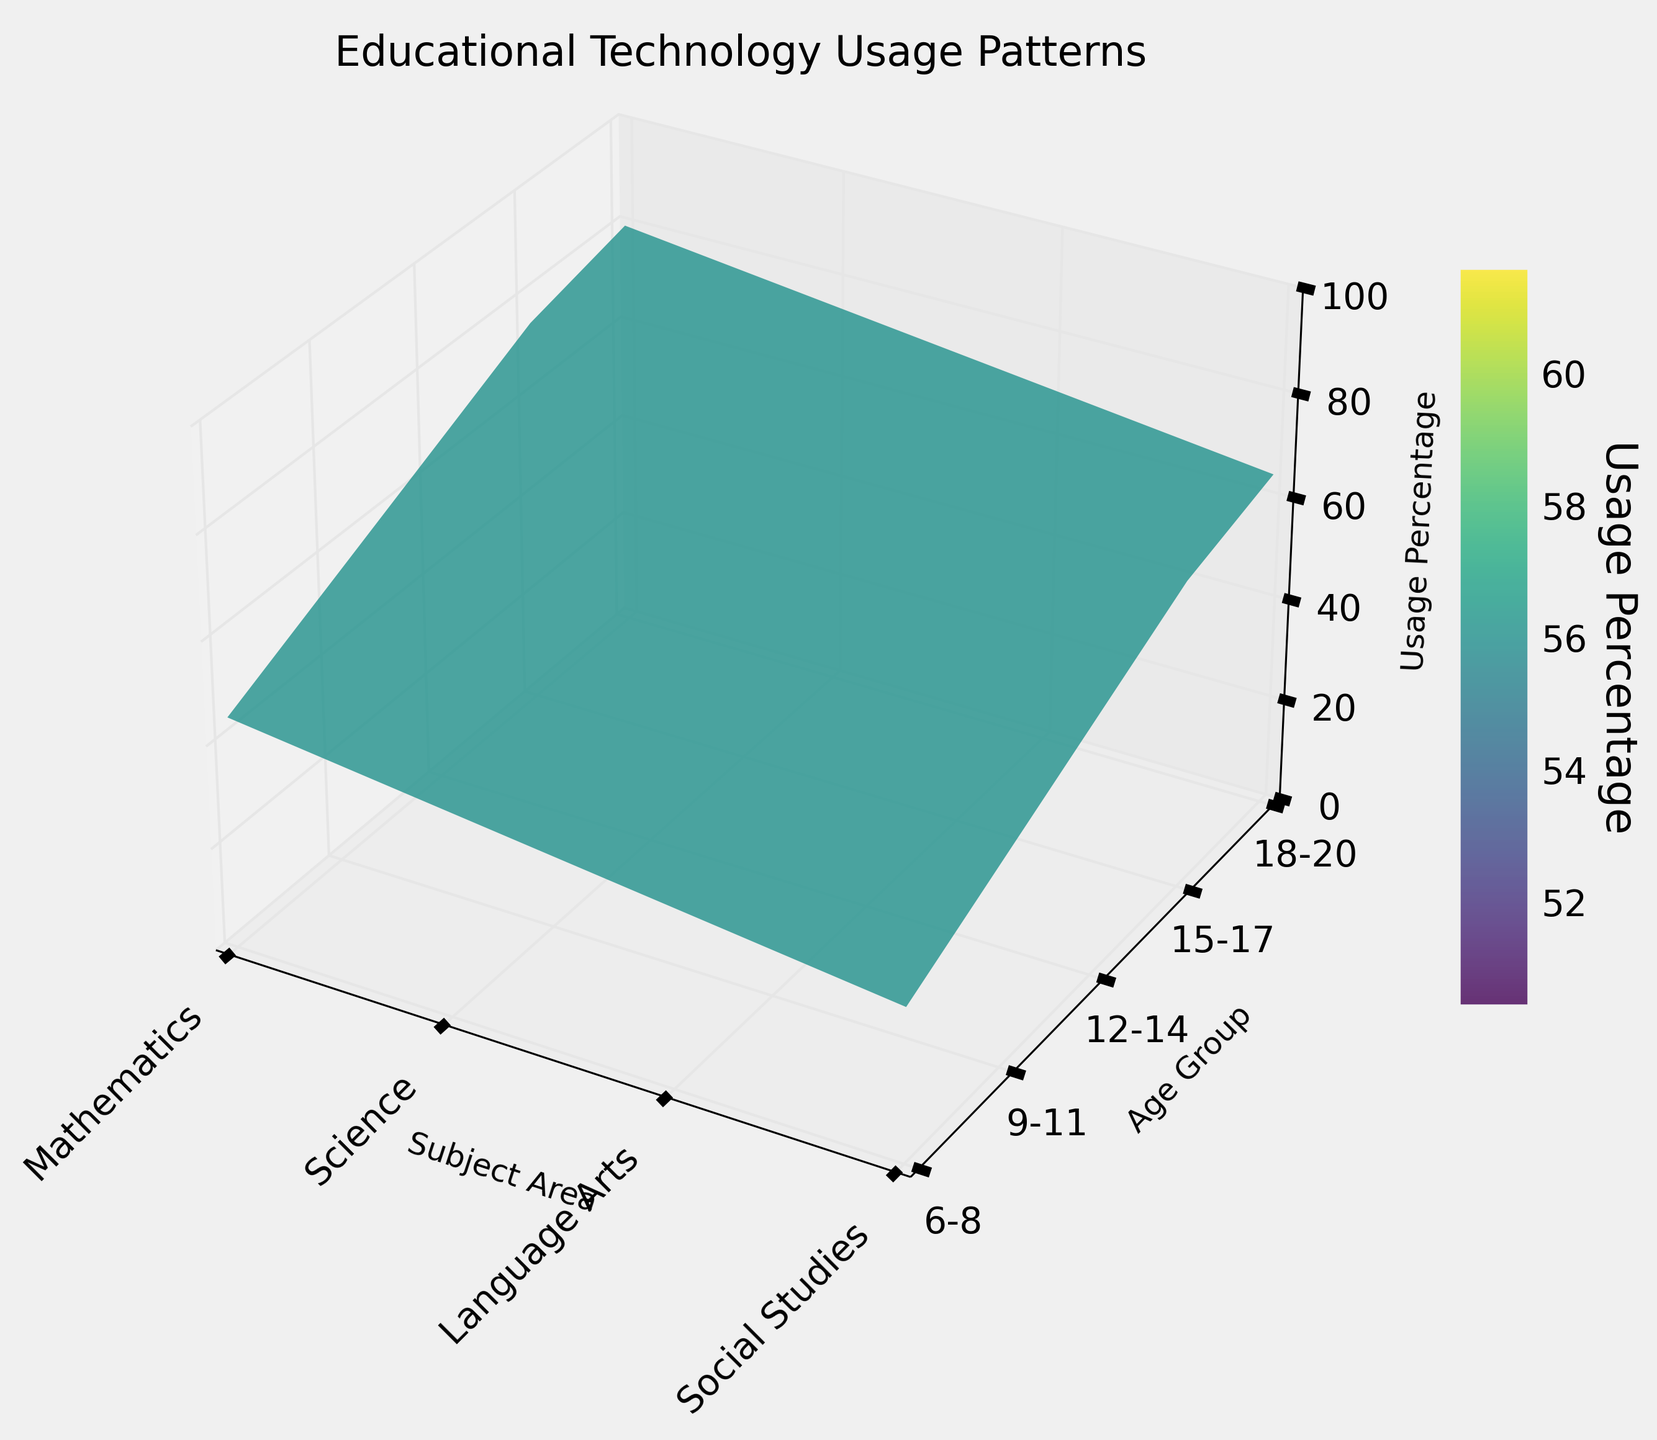What's the title of the plot? The title is located at the top center of the figure and reads "Educational Technology Usage Patterns".
Answer: Educational Technology Usage Patterns What's the label of the X-axis? The label of the X-axis is visible below the axis line and reads "Subject Area".
Answer: Subject Area What's the highest usage percentage and which subject and age group does it belong to? The highest peak in the plot represents the maximum usage percentage. It is at the intersection corresponding to "Mathematics" and the "18-20" age group, showing a usage percentage of 80%.
Answer: 80%, Mathematics, 18-20 Compare the usage percentage for Science between the age groups 6-8 and 15-17. Which age group has higher usage? By comparing the height of the surfaces for Science at the positions corresponding to these age groups, it shows that the 15-17 age group has a higher usage percentage (70%) than the 6-8 age group (40%).
Answer: 15-17 What's the average usage percentage for Mathematics across all age groups? Summing up the usage percentages for Mathematics across all age groups: 45 (6-8) + 55 (9-11) + 65 (12-14) + 75 (15-17) + 80 (18-20) = 320. Dividing by the number of age groups (5): 320 / 5 gives an average of 64%.
Answer: 64% For the 12-14 age group, which subject has the lowest usage percentage, and what is it? Looking at the usage percentages for the 12-14 age group, the lowest value corresponds to "Social Studies", which is 50%.
Answer: Social Studies, 50% Which subject area shows the most consistent usage percentage across all age groups? To determine the most consistent subject, look for the least variation in height along the Z-axis for each subject. "Language Arts" shows a consistent increase: 35 (6-8), 45 (9-11), 55 (12-14), 65 (15-17), 70 (18-20).
Answer: Language Arts How much is the difference in usage percentage between Mathematics and Social Studies for the 18-20 age group? The usage percentage for Mathematics in the 18-20 age group is 80%, and for Social Studies, it is 65%. The difference is 80 - 65 = 15%.
Answer: 15% Which age group shows the greatest increase in usage percentage for Science compared to the previous age group? By calculating the increase between each pair of consecutive age groups: 6-8 to 9-11 (50-40=10), 9-11 to 12-14 (60-50=10), 12-14 to 15-17 (70-60=10), 15-17 to 18-20 (75-70=5). The greatest increase is from 6-8 to 9-11, 9-11 to 12-14, and 12-14 to 15-17, which are all 10%.
Answer: 10% What is the overall trend for usage percentages across age groups for Social Studies? Observing the Z-axis values for Social Studies across age groups, there is a consistent increase: 30 (6-8), 40 (9-11), 50 (12-14), 60 (15-17), 65 (18-20).
Answer: Increasing 